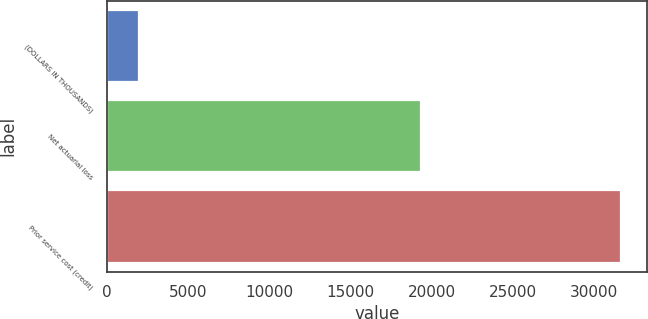Convert chart to OTSL. <chart><loc_0><loc_0><loc_500><loc_500><bar_chart><fcel>(DOLLARS IN THOUSANDS)<fcel>Net actuarial loss<fcel>Prior service cost (credit)<nl><fcel>2016<fcel>19336<fcel>31664<nl></chart> 